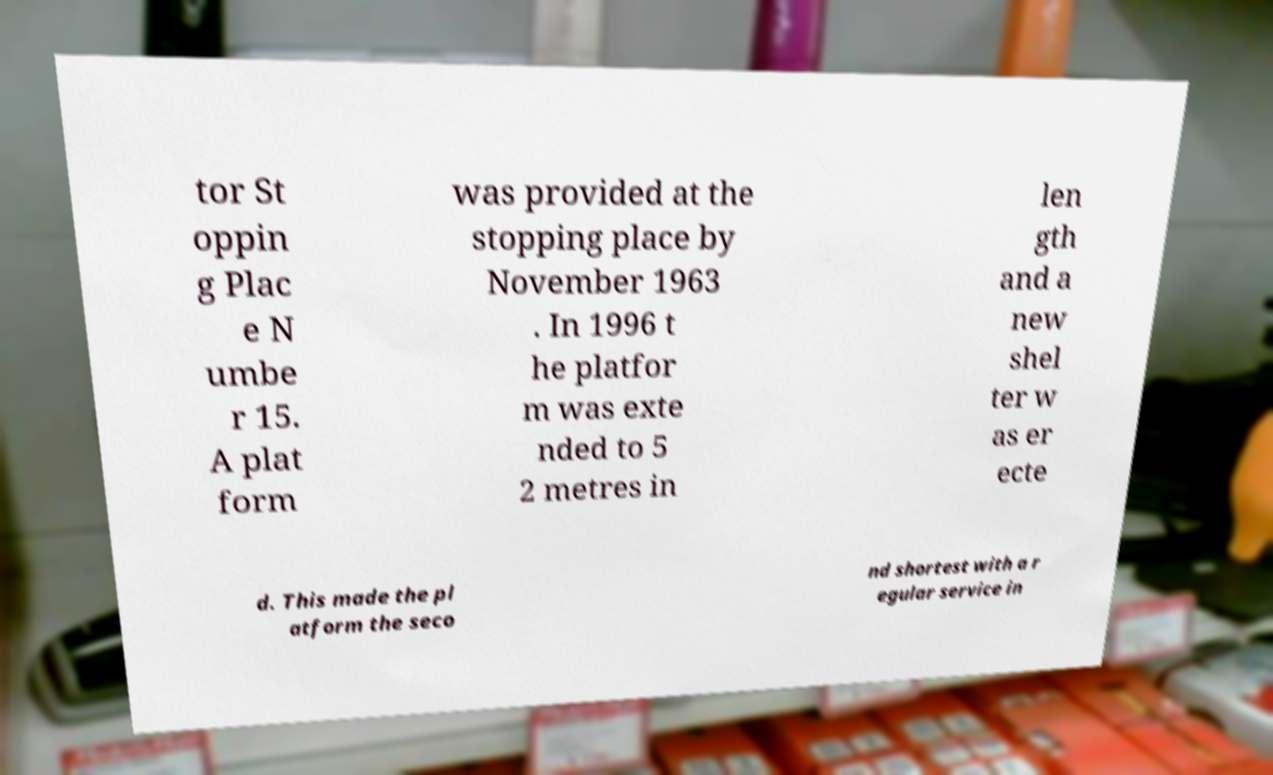Can you accurately transcribe the text from the provided image for me? tor St oppin g Plac e N umbe r 15. A plat form was provided at the stopping place by November 1963 . In 1996 t he platfor m was exte nded to 5 2 metres in len gth and a new shel ter w as er ecte d. This made the pl atform the seco nd shortest with a r egular service in 